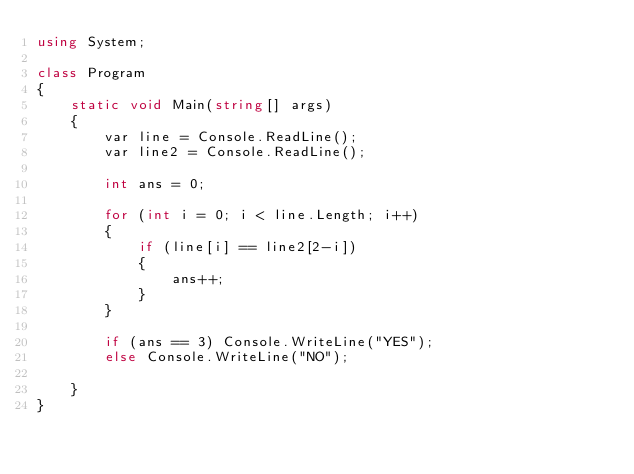<code> <loc_0><loc_0><loc_500><loc_500><_C#_>using System;

class Program
{
    static void Main(string[] args)
    {
        var line = Console.ReadLine();
        var line2 = Console.ReadLine();

        int ans = 0;

        for (int i = 0; i < line.Length; i++)
        {
            if (line[i] == line2[2-i])
            {
                ans++;
            }
        }

        if (ans == 3) Console.WriteLine("YES");
        else Console.WriteLine("NO");
        
    }
}
</code> 